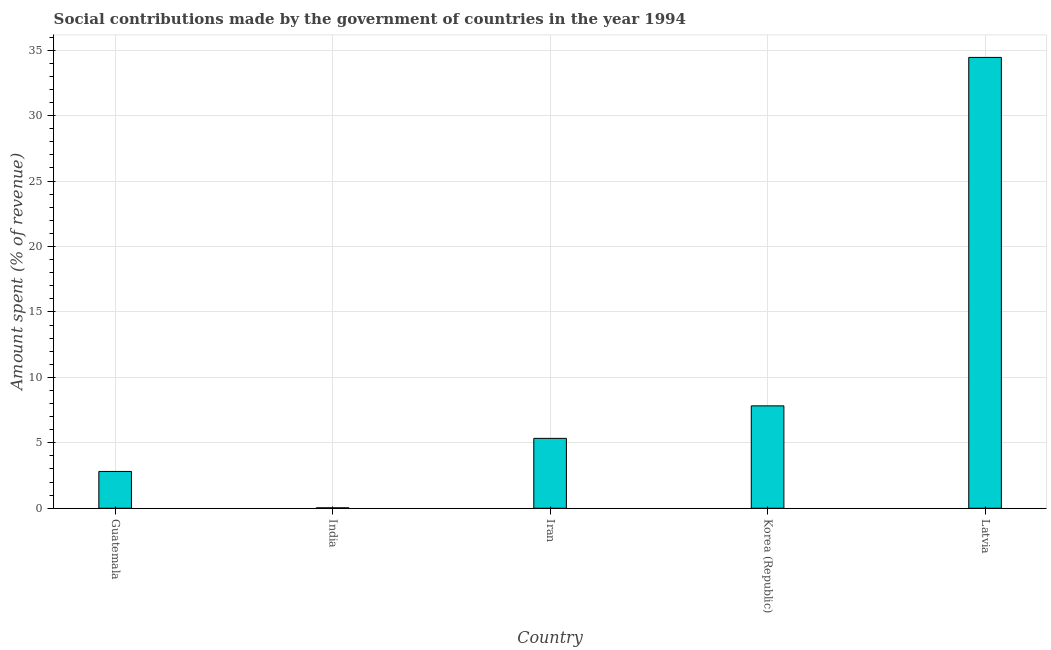Does the graph contain any zero values?
Provide a succinct answer. No. Does the graph contain grids?
Make the answer very short. Yes. What is the title of the graph?
Ensure brevity in your answer.  Social contributions made by the government of countries in the year 1994. What is the label or title of the Y-axis?
Give a very brief answer. Amount spent (% of revenue). What is the amount spent in making social contributions in India?
Give a very brief answer. 0.03. Across all countries, what is the maximum amount spent in making social contributions?
Keep it short and to the point. 34.44. Across all countries, what is the minimum amount spent in making social contributions?
Your answer should be very brief. 0.03. In which country was the amount spent in making social contributions maximum?
Give a very brief answer. Latvia. What is the sum of the amount spent in making social contributions?
Provide a short and direct response. 50.45. What is the difference between the amount spent in making social contributions in India and Latvia?
Your response must be concise. -34.41. What is the average amount spent in making social contributions per country?
Provide a succinct answer. 10.09. What is the median amount spent in making social contributions?
Your response must be concise. 5.34. What is the ratio of the amount spent in making social contributions in India to that in Korea (Republic)?
Ensure brevity in your answer.  0. What is the difference between the highest and the second highest amount spent in making social contributions?
Offer a terse response. 26.62. What is the difference between the highest and the lowest amount spent in making social contributions?
Provide a short and direct response. 34.41. Are all the bars in the graph horizontal?
Your answer should be compact. No. How many countries are there in the graph?
Give a very brief answer. 5. What is the Amount spent (% of revenue) of Guatemala?
Your response must be concise. 2.81. What is the Amount spent (% of revenue) in India?
Your response must be concise. 0.03. What is the Amount spent (% of revenue) of Iran?
Offer a very short reply. 5.34. What is the Amount spent (% of revenue) in Korea (Republic)?
Offer a very short reply. 7.82. What is the Amount spent (% of revenue) in Latvia?
Make the answer very short. 34.44. What is the difference between the Amount spent (% of revenue) in Guatemala and India?
Offer a terse response. 2.78. What is the difference between the Amount spent (% of revenue) in Guatemala and Iran?
Your answer should be very brief. -2.53. What is the difference between the Amount spent (% of revenue) in Guatemala and Korea (Republic)?
Offer a terse response. -5.01. What is the difference between the Amount spent (% of revenue) in Guatemala and Latvia?
Provide a succinct answer. -31.63. What is the difference between the Amount spent (% of revenue) in India and Iran?
Ensure brevity in your answer.  -5.31. What is the difference between the Amount spent (% of revenue) in India and Korea (Republic)?
Your answer should be very brief. -7.79. What is the difference between the Amount spent (% of revenue) in India and Latvia?
Make the answer very short. -34.41. What is the difference between the Amount spent (% of revenue) in Iran and Korea (Republic)?
Your answer should be very brief. -2.48. What is the difference between the Amount spent (% of revenue) in Iran and Latvia?
Your answer should be compact. -29.1. What is the difference between the Amount spent (% of revenue) in Korea (Republic) and Latvia?
Offer a very short reply. -26.62. What is the ratio of the Amount spent (% of revenue) in Guatemala to that in India?
Your answer should be very brief. 80.63. What is the ratio of the Amount spent (% of revenue) in Guatemala to that in Iran?
Ensure brevity in your answer.  0.53. What is the ratio of the Amount spent (% of revenue) in Guatemala to that in Korea (Republic)?
Ensure brevity in your answer.  0.36. What is the ratio of the Amount spent (% of revenue) in Guatemala to that in Latvia?
Provide a short and direct response. 0.08. What is the ratio of the Amount spent (% of revenue) in India to that in Iran?
Give a very brief answer. 0.01. What is the ratio of the Amount spent (% of revenue) in India to that in Korea (Republic)?
Give a very brief answer. 0. What is the ratio of the Amount spent (% of revenue) in India to that in Latvia?
Give a very brief answer. 0. What is the ratio of the Amount spent (% of revenue) in Iran to that in Korea (Republic)?
Offer a very short reply. 0.68. What is the ratio of the Amount spent (% of revenue) in Iran to that in Latvia?
Your answer should be compact. 0.15. What is the ratio of the Amount spent (% of revenue) in Korea (Republic) to that in Latvia?
Offer a terse response. 0.23. 